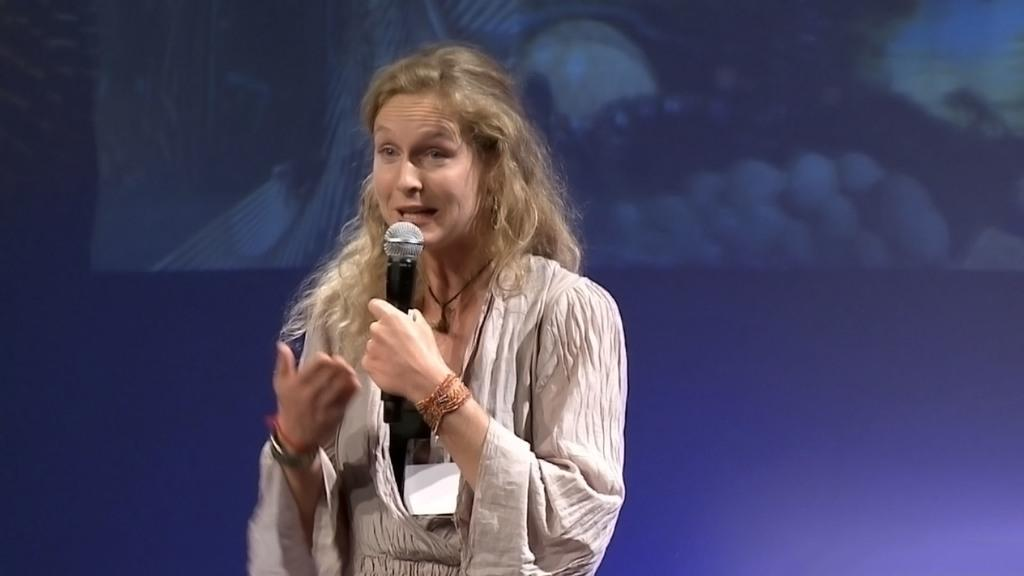Who is the main subject in the image? There is a girl in the image. What is the girl doing in the image? The girl is standing in the image. What object is the girl holding in the image? The girl is holding a microphone in the image. What can be seen in the background of the image? There is a screen in the background of the image. What type of cap is the girl wearing in the image? There is no cap visible in the image; the girl is not wearing one. Is the girl standing in a garden in the image? The image does not show a garden, so it cannot be determined if the girl is standing in one. 